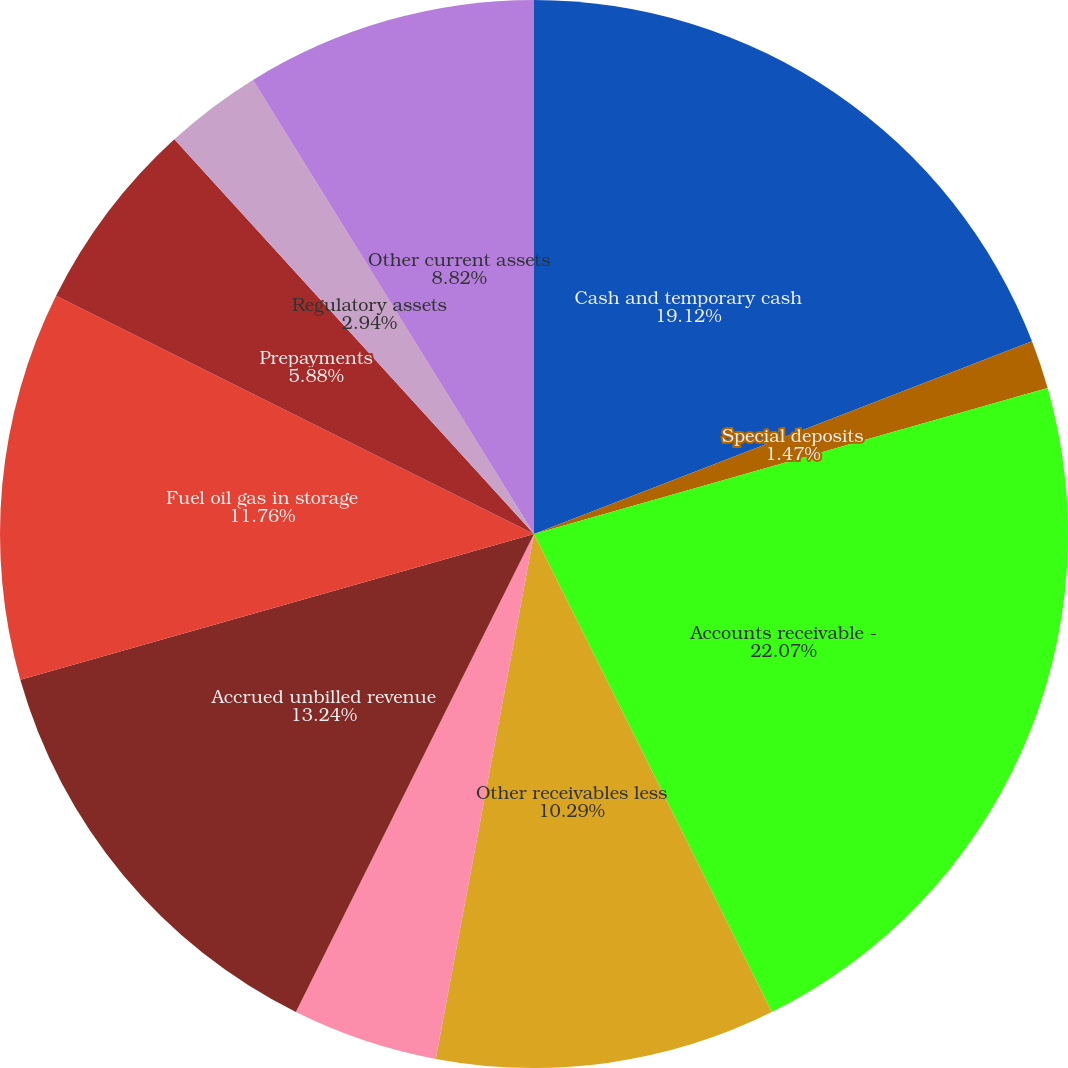<chart> <loc_0><loc_0><loc_500><loc_500><pie_chart><fcel>Cash and temporary cash<fcel>Special deposits<fcel>Accounts receivable -<fcel>Other receivables less<fcel>Income taxes receivable<fcel>Accrued unbilled revenue<fcel>Fuel oil gas in storage<fcel>Prepayments<fcel>Regulatory assets<fcel>Other current assets<nl><fcel>19.12%<fcel>1.47%<fcel>22.06%<fcel>10.29%<fcel>4.41%<fcel>13.24%<fcel>11.76%<fcel>5.88%<fcel>2.94%<fcel>8.82%<nl></chart> 